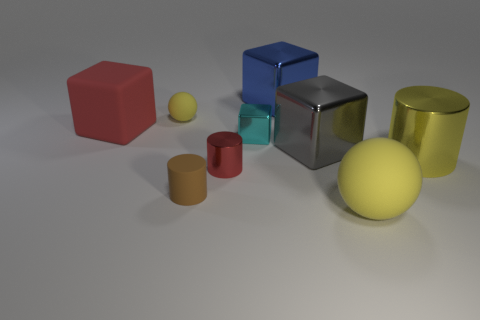Subtract all red cylinders. How many cylinders are left? 2 Subtract all yellow cylinders. How many cylinders are left? 2 Add 1 large green metal cylinders. How many objects exist? 10 Subtract 1 balls. How many balls are left? 1 Subtract all red spheres. Subtract all cyan cubes. How many spheres are left? 2 Subtract all brown cylinders. How many red blocks are left? 1 Subtract all big metal things. Subtract all big blue objects. How many objects are left? 5 Add 4 tiny red cylinders. How many tiny red cylinders are left? 5 Add 9 brown matte objects. How many brown matte objects exist? 10 Subtract 0 red spheres. How many objects are left? 9 